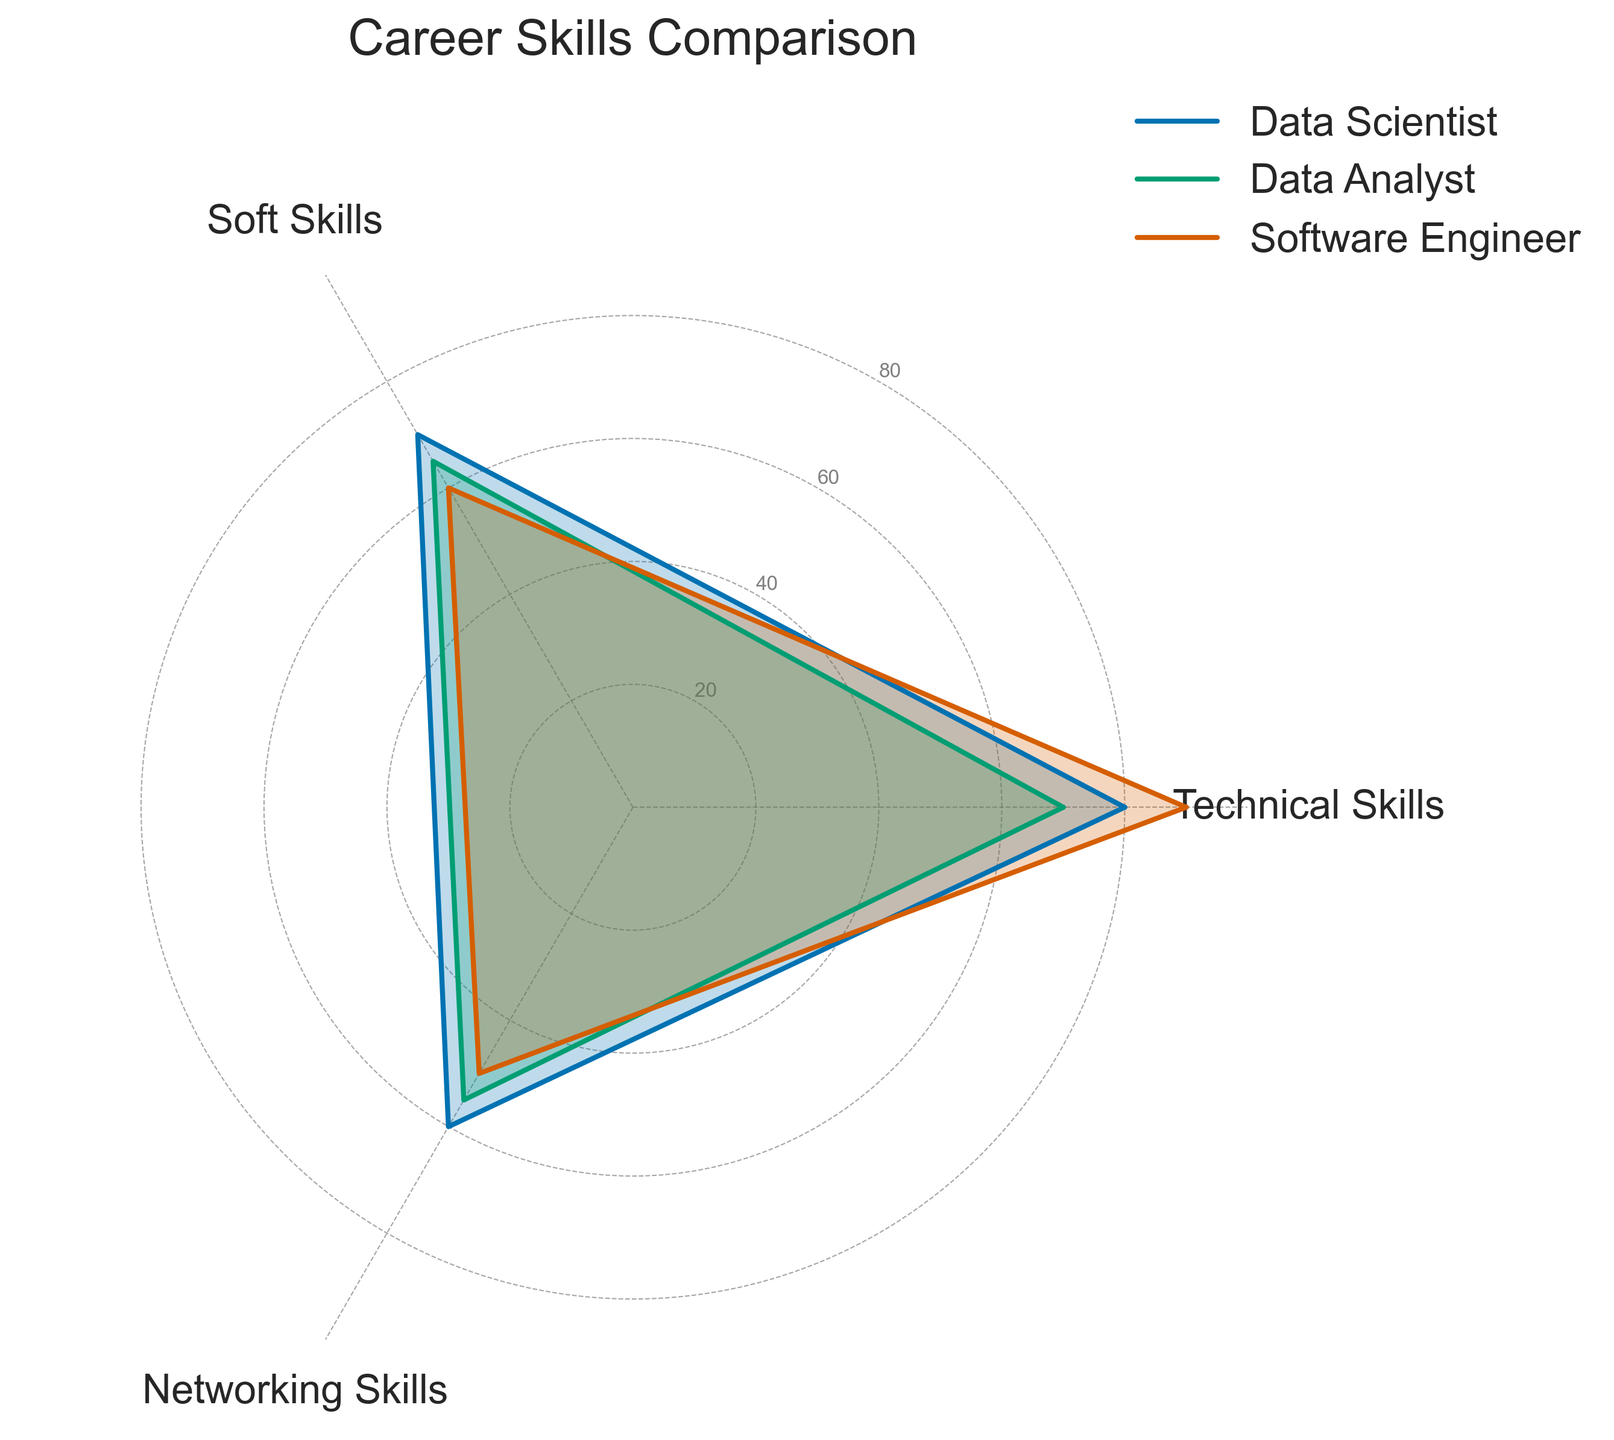What's the title of the figure? The title is shown at the top of the figure.
Answer: Career Skills Comparison Which skill has the highest value for the Data Scientist group? By looking at the Data Scientist line (marked in the legend), the point at the "Technical Skills" axis is the highest.
Answer: Technical Skills What are the y-axis labels shown in the figure? The y-axis labels can be seen along the rings in the figure.
Answer: 20, 40, 60, 80 Which group has the lowest value in Soft Skills? By comparing the points at the "Soft Skills" axis for all groups, find the lowest value. The Soft Skills value for Software Engineer is lowest.
Answer: Software Engineer How do the Networking Skills of Data Analyst compare to those of Software Engineer? Compare the points at the "Networking Skills" axis for both Data Analyst and Software Engineer. Data Analyst has a higher value of 55 compared to 50 for Software Engineer.
Answer: Data Analyst has higher Networking Skills What's the average value of Technical Skills for all the groups? Sum the Technical Skills values for Data Scientist (80), Data Analyst (70), and Software Engineer (90) and divide by the number of groups (3). (80 + 70 + 90) / 3 = 240 / 3 = 80
Answer: 80 Which group has the highest average skill value across all categories? Calculate the average value of Technical, Soft, and Networking Skills for each group, then compare them. Data Scientist: (80+70+60)/3 = 70, Data Analyst: (70+65+55)/3 = 63.33, Software Engineer: (90+60+50)/3 = 66.67. Data Scientist has the highest average.
Answer: Data Scientist Which skill category shows the greatest range (difference between highest and lowest values) across all groups? Find the range by subtracting the lowest value from the highest value in each skill category. Technical Skills: 90 - 70 = 20, Soft Skills: 70 - 60 = 10, Networking Skills: 60 - 50 = 10. Technical Skills have the highest range.
Answer: Technical Skills What is the sum of all skill values for the Software Engineer group? Add the values for Technical (90), Soft (60), and Networking Skills (50) for the Software Engineer group. 90 + 60 + 50 = 200
Answer: 200 